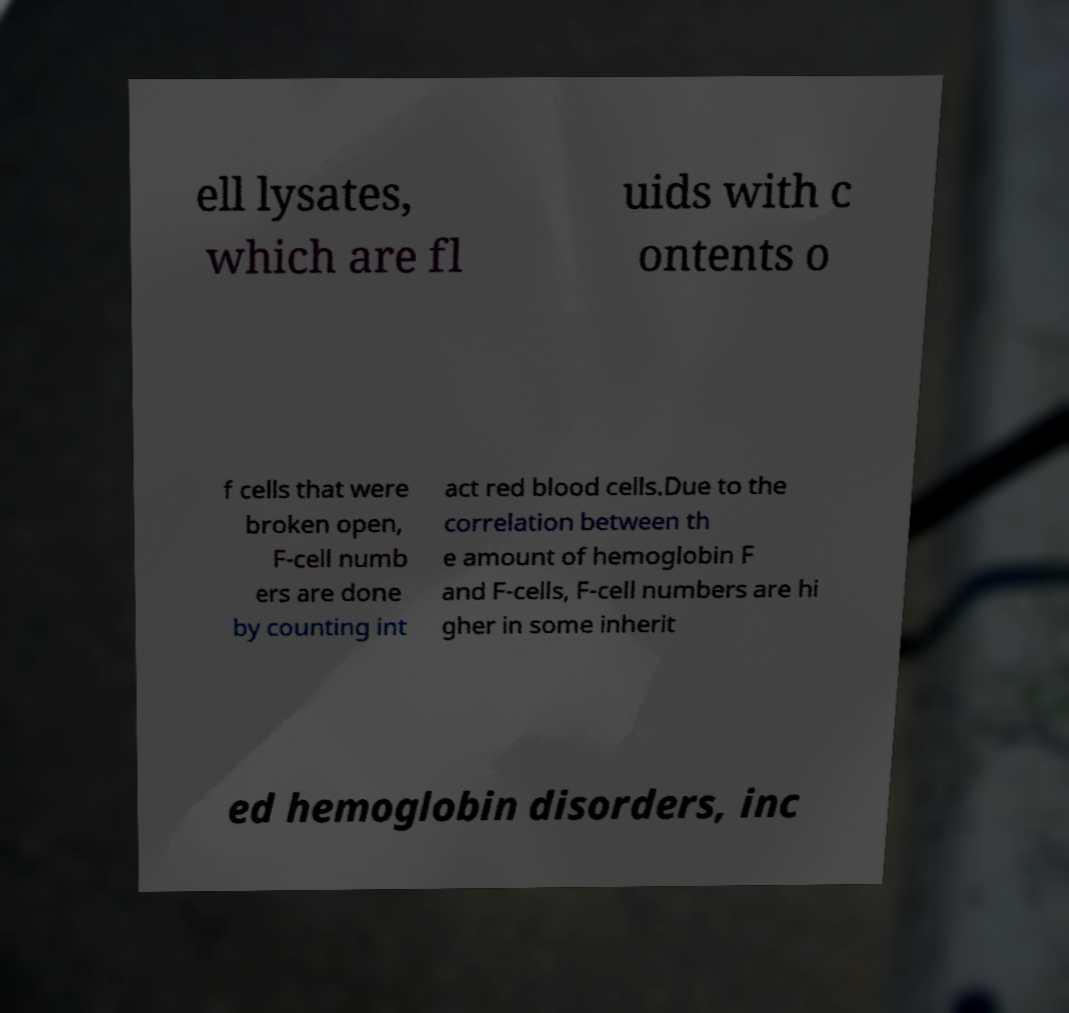Please read and relay the text visible in this image. What does it say? ell lysates, which are fl uids with c ontents o f cells that were broken open, F-cell numb ers are done by counting int act red blood cells.Due to the correlation between th e amount of hemoglobin F and F-cells, F-cell numbers are hi gher in some inherit ed hemoglobin disorders, inc 